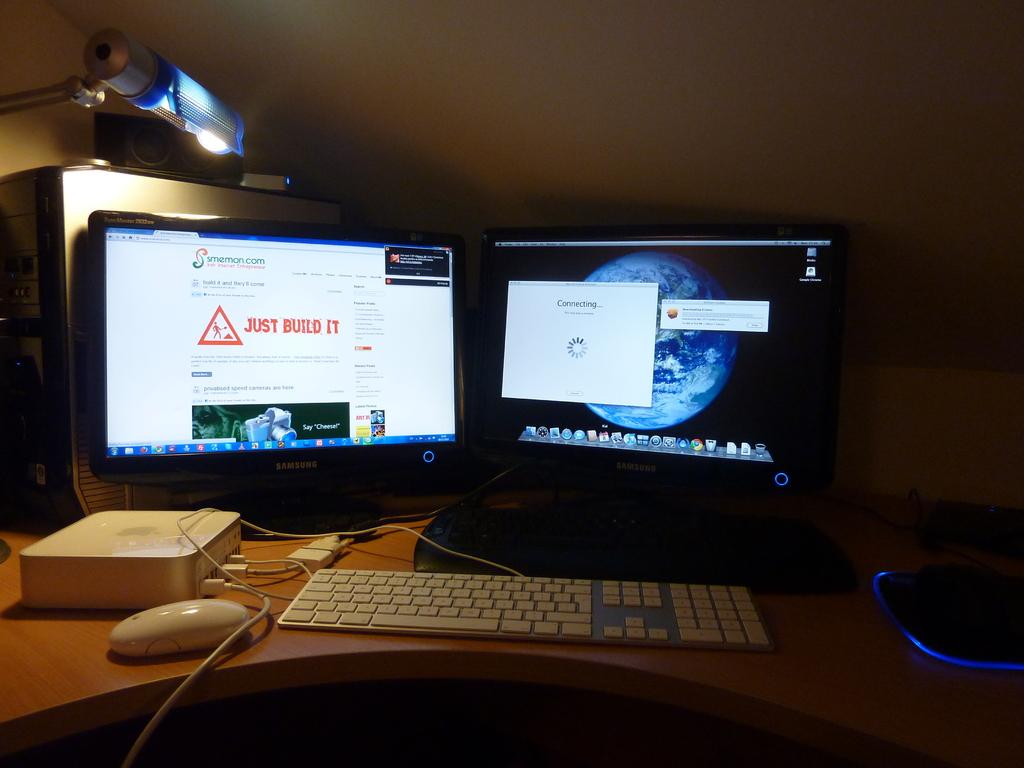<image>
Create a compact narrative representing the image presented. Two monitors which are turned on with the one on the left having the phrase "Just build it". 